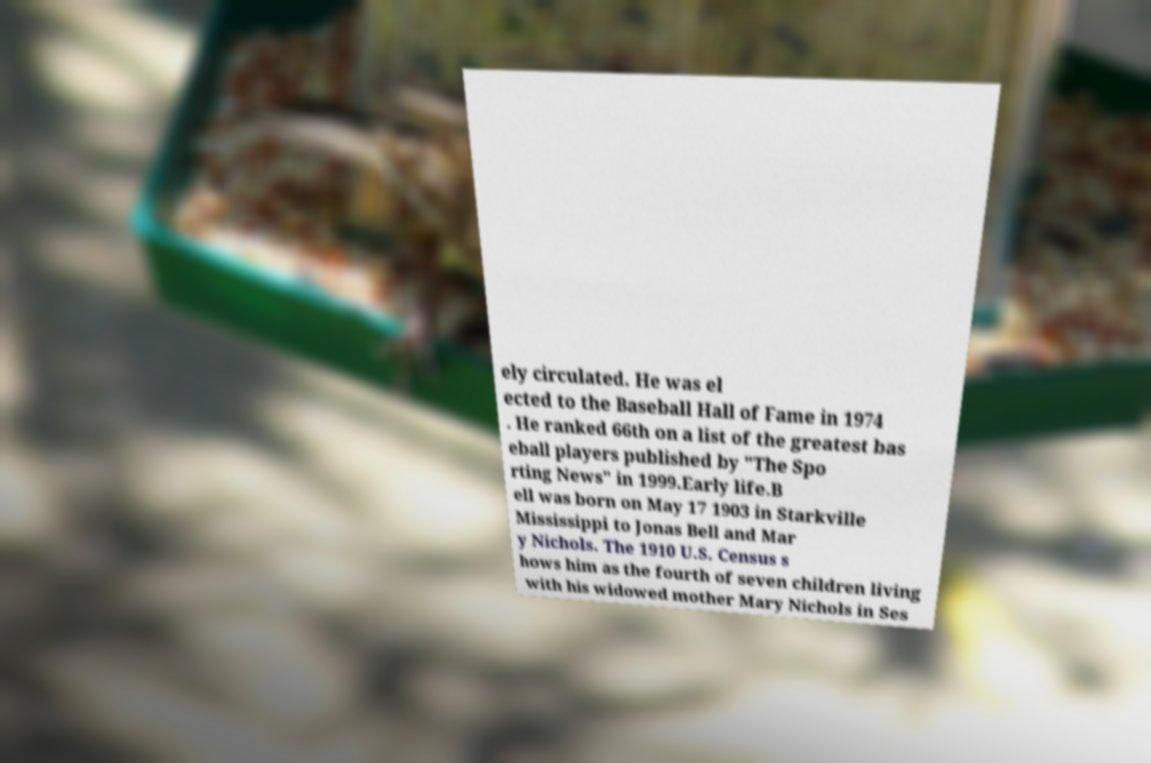Can you read and provide the text displayed in the image?This photo seems to have some interesting text. Can you extract and type it out for me? ely circulated. He was el ected to the Baseball Hall of Fame in 1974 . He ranked 66th on a list of the greatest bas eball players published by "The Spo rting News" in 1999.Early life.B ell was born on May 17 1903 in Starkville Mississippi to Jonas Bell and Mar y Nichols. The 1910 U.S. Census s hows him as the fourth of seven children living with his widowed mother Mary Nichols in Ses 